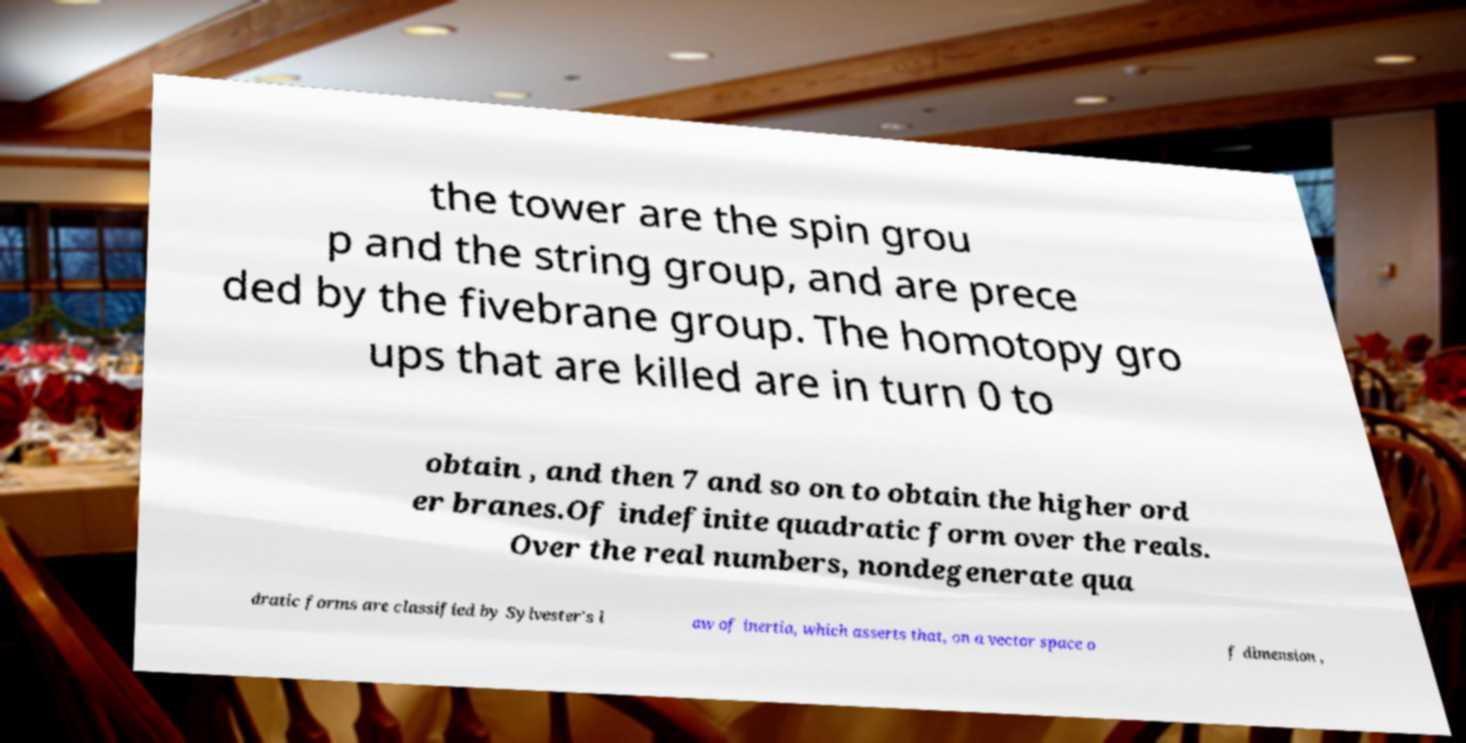For documentation purposes, I need the text within this image transcribed. Could you provide that? the tower are the spin grou p and the string group, and are prece ded by the fivebrane group. The homotopy gro ups that are killed are in turn 0 to obtain , and then 7 and so on to obtain the higher ord er branes.Of indefinite quadratic form over the reals. Over the real numbers, nondegenerate qua dratic forms are classified by Sylvester's l aw of inertia, which asserts that, on a vector space o f dimension , 